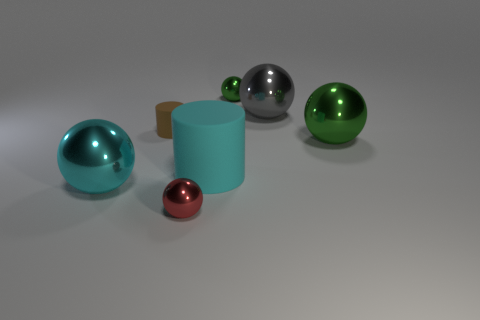Subtract all yellow cylinders. How many green balls are left? 2 Subtract 3 balls. How many balls are left? 2 Subtract all green balls. How many balls are left? 3 Add 3 tiny red rubber cubes. How many objects exist? 10 Subtract all cyan cylinders. How many cylinders are left? 1 Add 2 yellow rubber cubes. How many yellow rubber cubes exist? 2 Subtract 1 cyan balls. How many objects are left? 6 Subtract all spheres. How many objects are left? 2 Subtract all yellow spheres. Subtract all brown blocks. How many spheres are left? 5 Subtract all big cyan balls. Subtract all large cyan matte things. How many objects are left? 5 